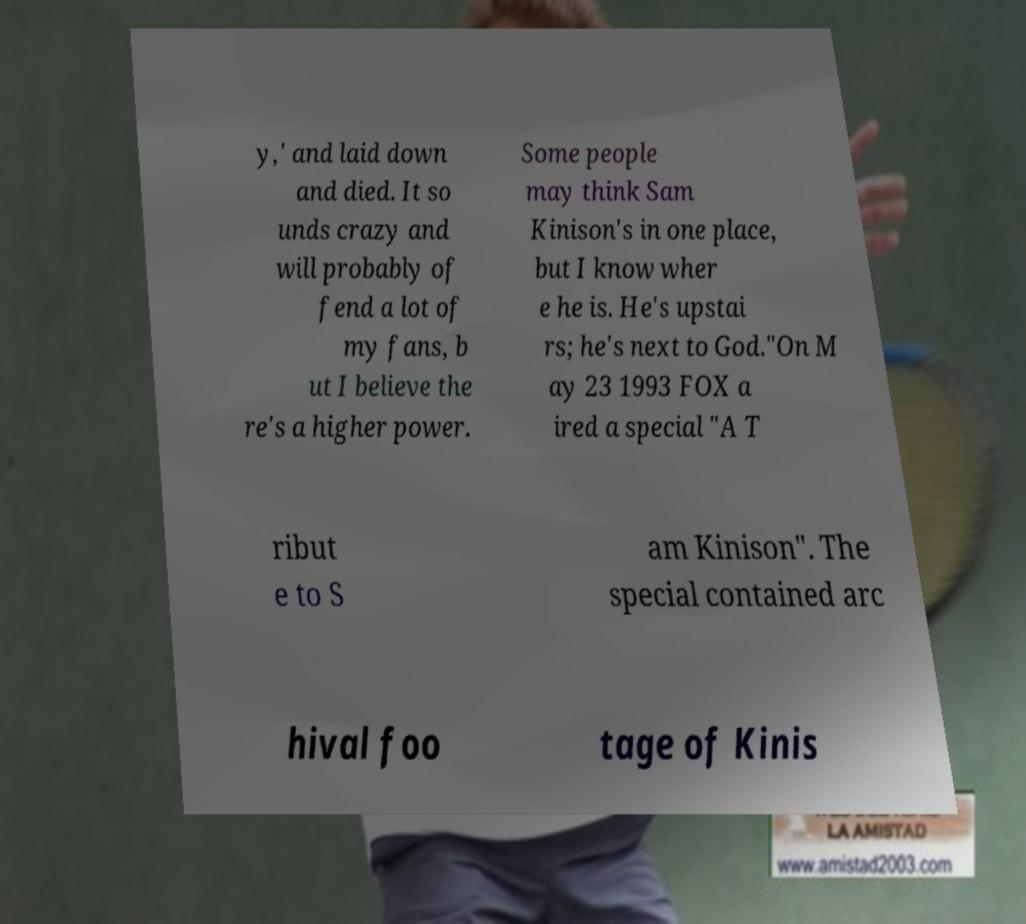For documentation purposes, I need the text within this image transcribed. Could you provide that? y,' and laid down and died. It so unds crazy and will probably of fend a lot of my fans, b ut I believe the re's a higher power. Some people may think Sam Kinison's in one place, but I know wher e he is. He's upstai rs; he's next to God."On M ay 23 1993 FOX a ired a special "A T ribut e to S am Kinison". The special contained arc hival foo tage of Kinis 